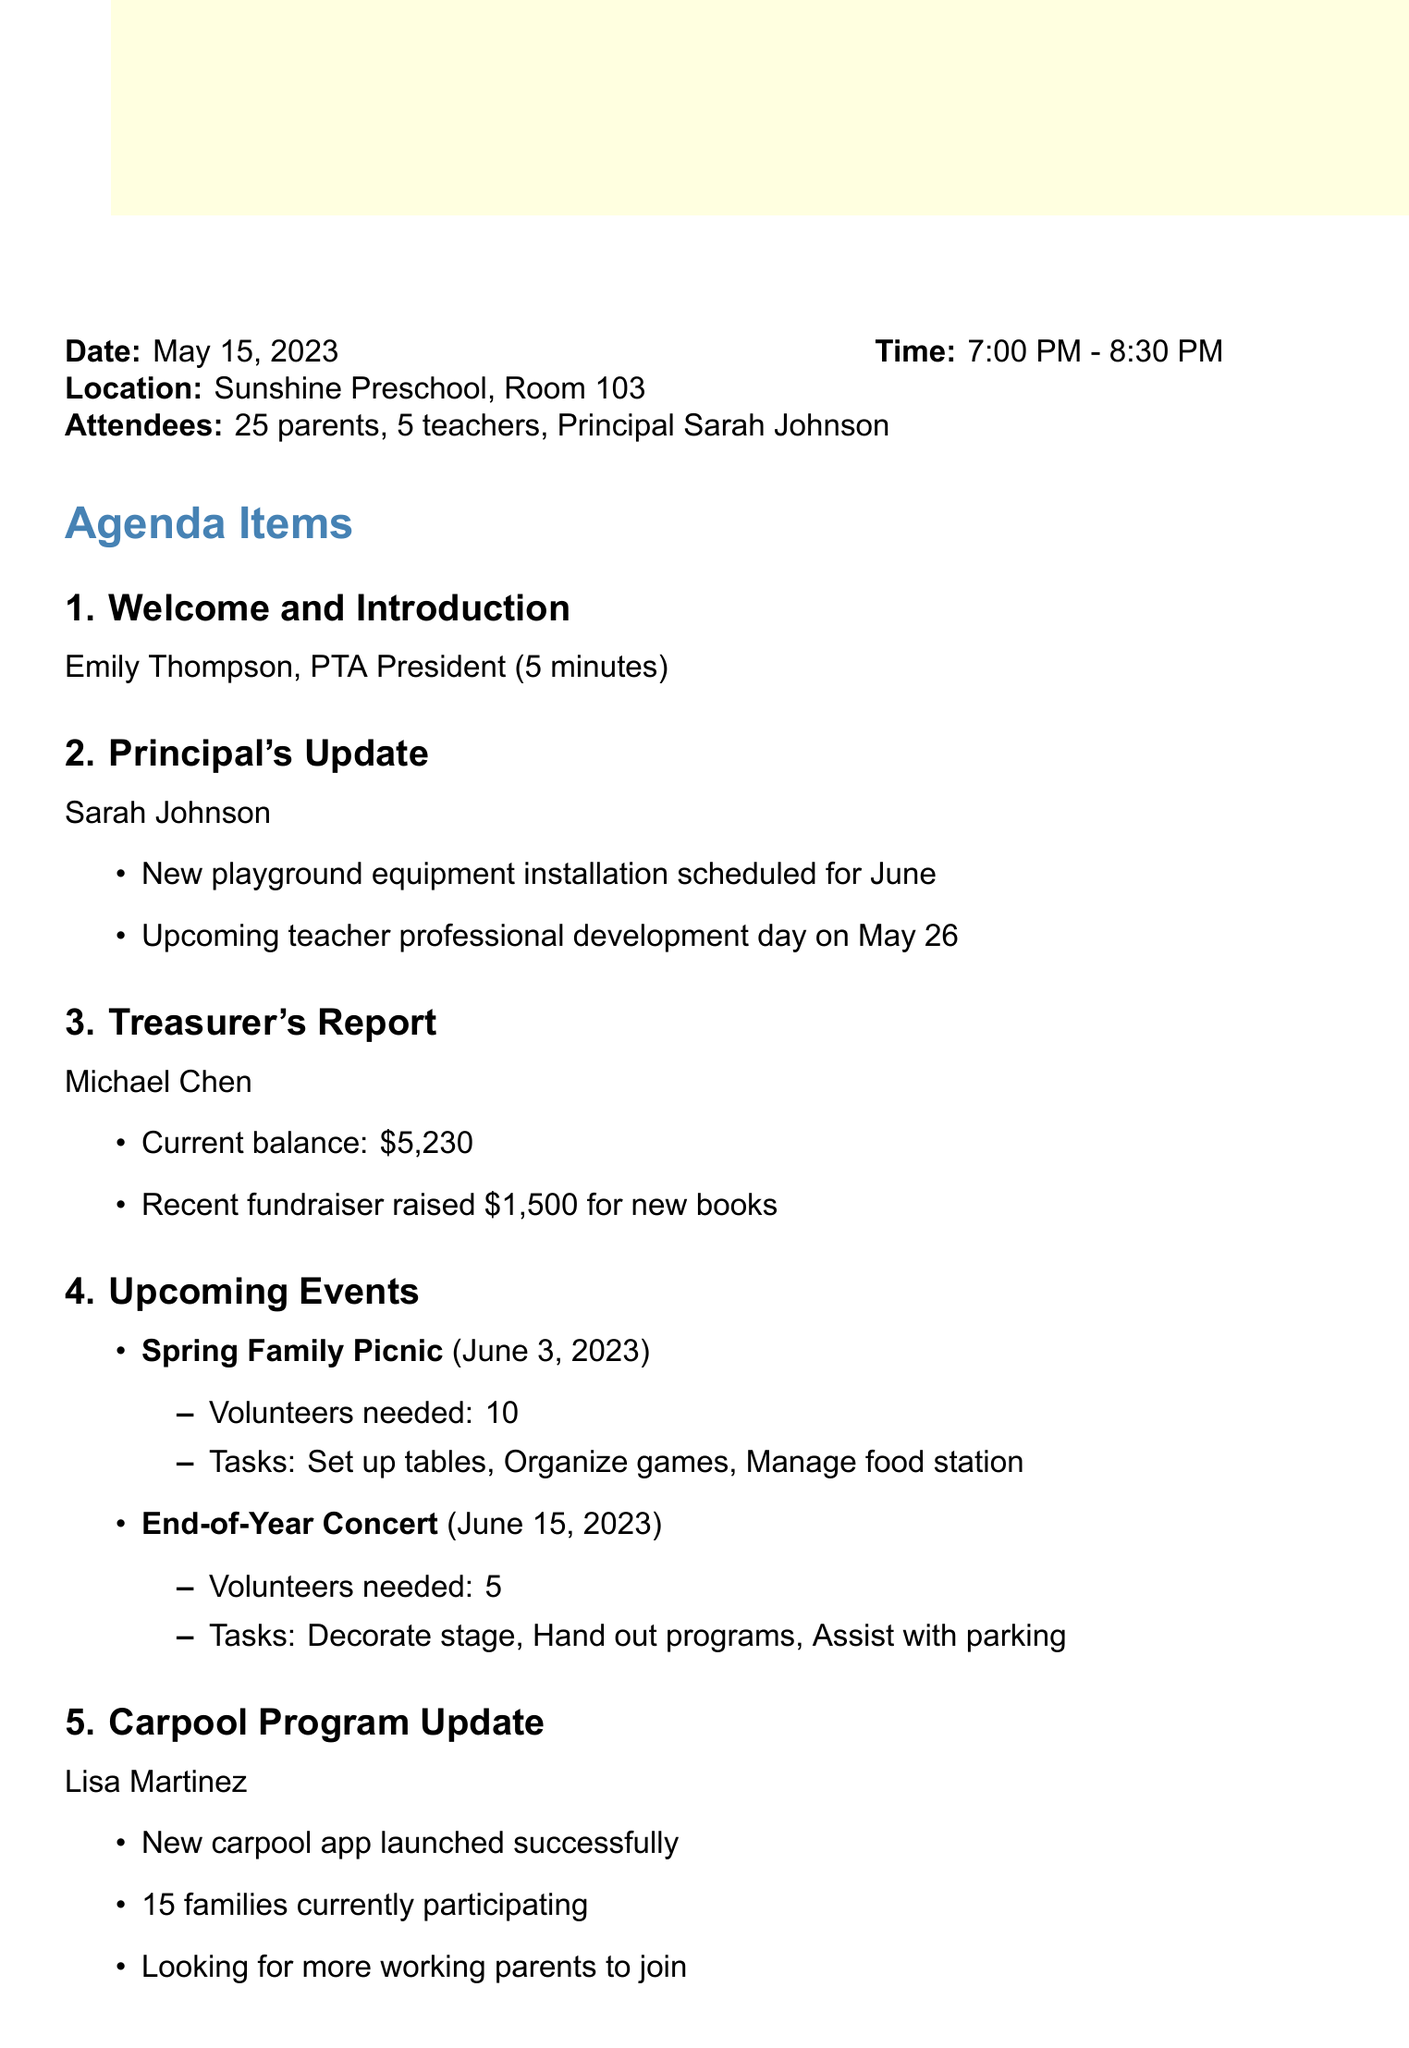What is the date of the meeting? The date of the meeting is specified at the beginning of the document.
Answer: May 15, 2023 How many volunteers are needed for the Spring Family Picnic? The number of volunteers needed is listed in the upcoming events section.
Answer: 10 Who gave the Treasurer's Report? The speaker for the Treasurer's Report is mentioned in the agenda items.
Answer: Michael Chen What is the goal of the Summer Reading Program? The goal is stated by the speaker of the Summer Reading Program.
Answer: 20 books per child over summer break How many families are currently participating in the carpool program? The number of participating families is shared during the carpool program update.
Answer: 15 When is the next PTA meeting scheduled? The date of the next meeting is provided at the end of the document.
Answer: September 12, 2023 What tasks are volunteers needed for at the End-of-Year Concert? The tasks for volunteers are detailed under the upcoming events section.
Answer: Decorate stage, Hand out programs, Assist with parking Who is the PTA President? The name of the PTA President is mentioned in the welcome and introduction segment.
Answer: Emily Thompson Which teacher provided the update on the Summer Reading Program? The teacher who spoke about the Summer Reading Program is listed in the agenda.
Answer: Ms. Anderson 